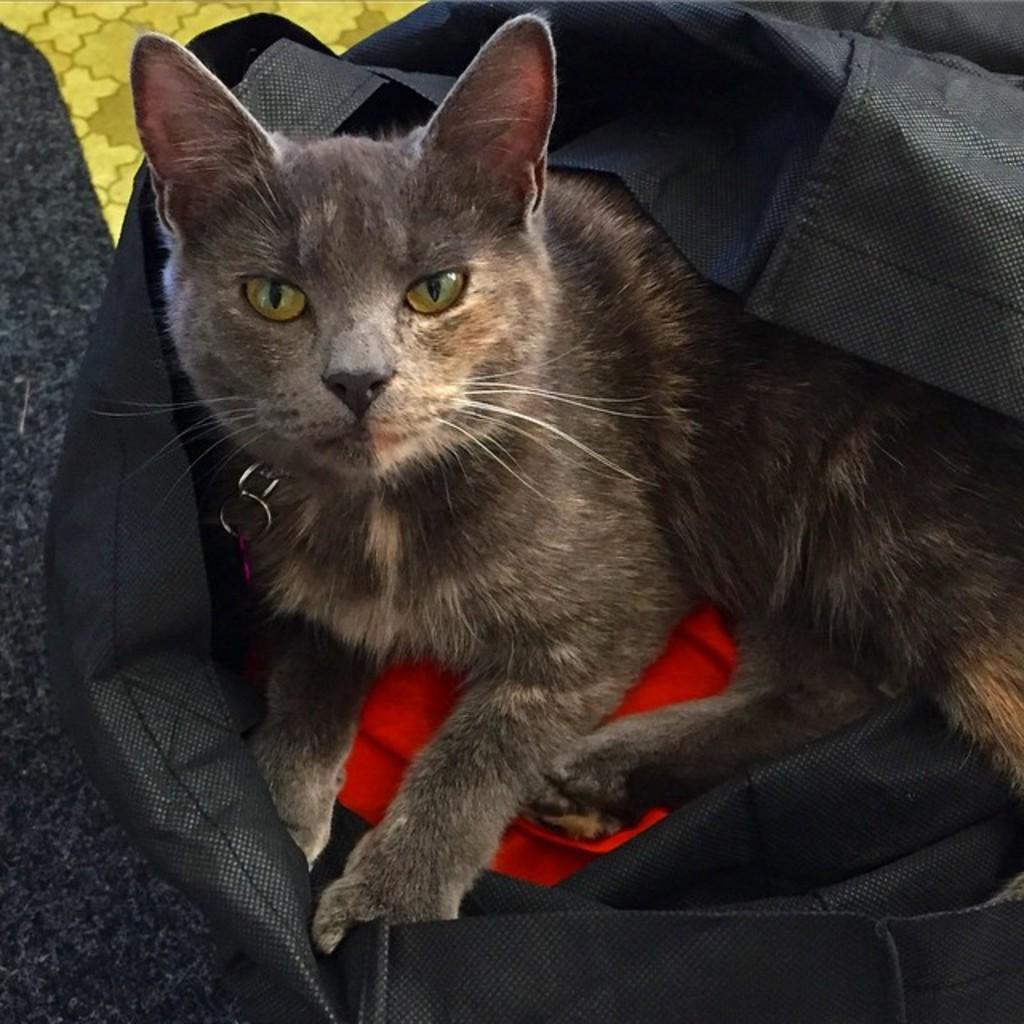Could you give a brief overview of what you see in this image? In this picture I can see a cat in the bag and it looks like a mat on the floor 